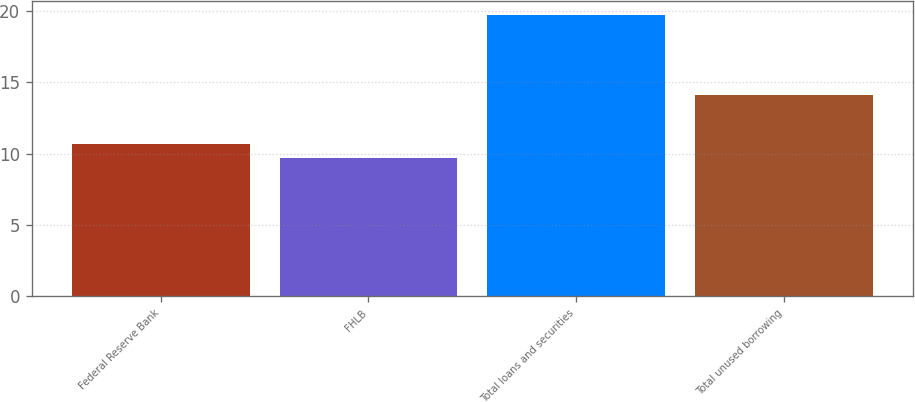Convert chart. <chart><loc_0><loc_0><loc_500><loc_500><bar_chart><fcel>Federal Reserve Bank<fcel>FHLB<fcel>Total loans and securities<fcel>Total unused borrowing<nl><fcel>10.7<fcel>9.7<fcel>19.7<fcel>14.1<nl></chart> 